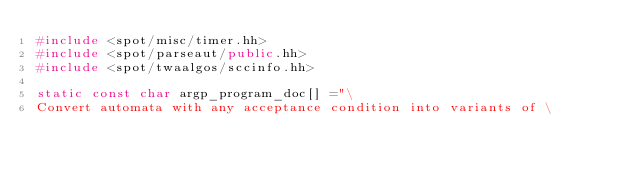Convert code to text. <code><loc_0><loc_0><loc_500><loc_500><_C++_>#include <spot/misc/timer.hh>
#include <spot/parseaut/public.hh>
#include <spot/twaalgos/sccinfo.hh>

static const char argp_program_doc[] ="\
Convert automata with any acceptance condition into variants of \</code> 